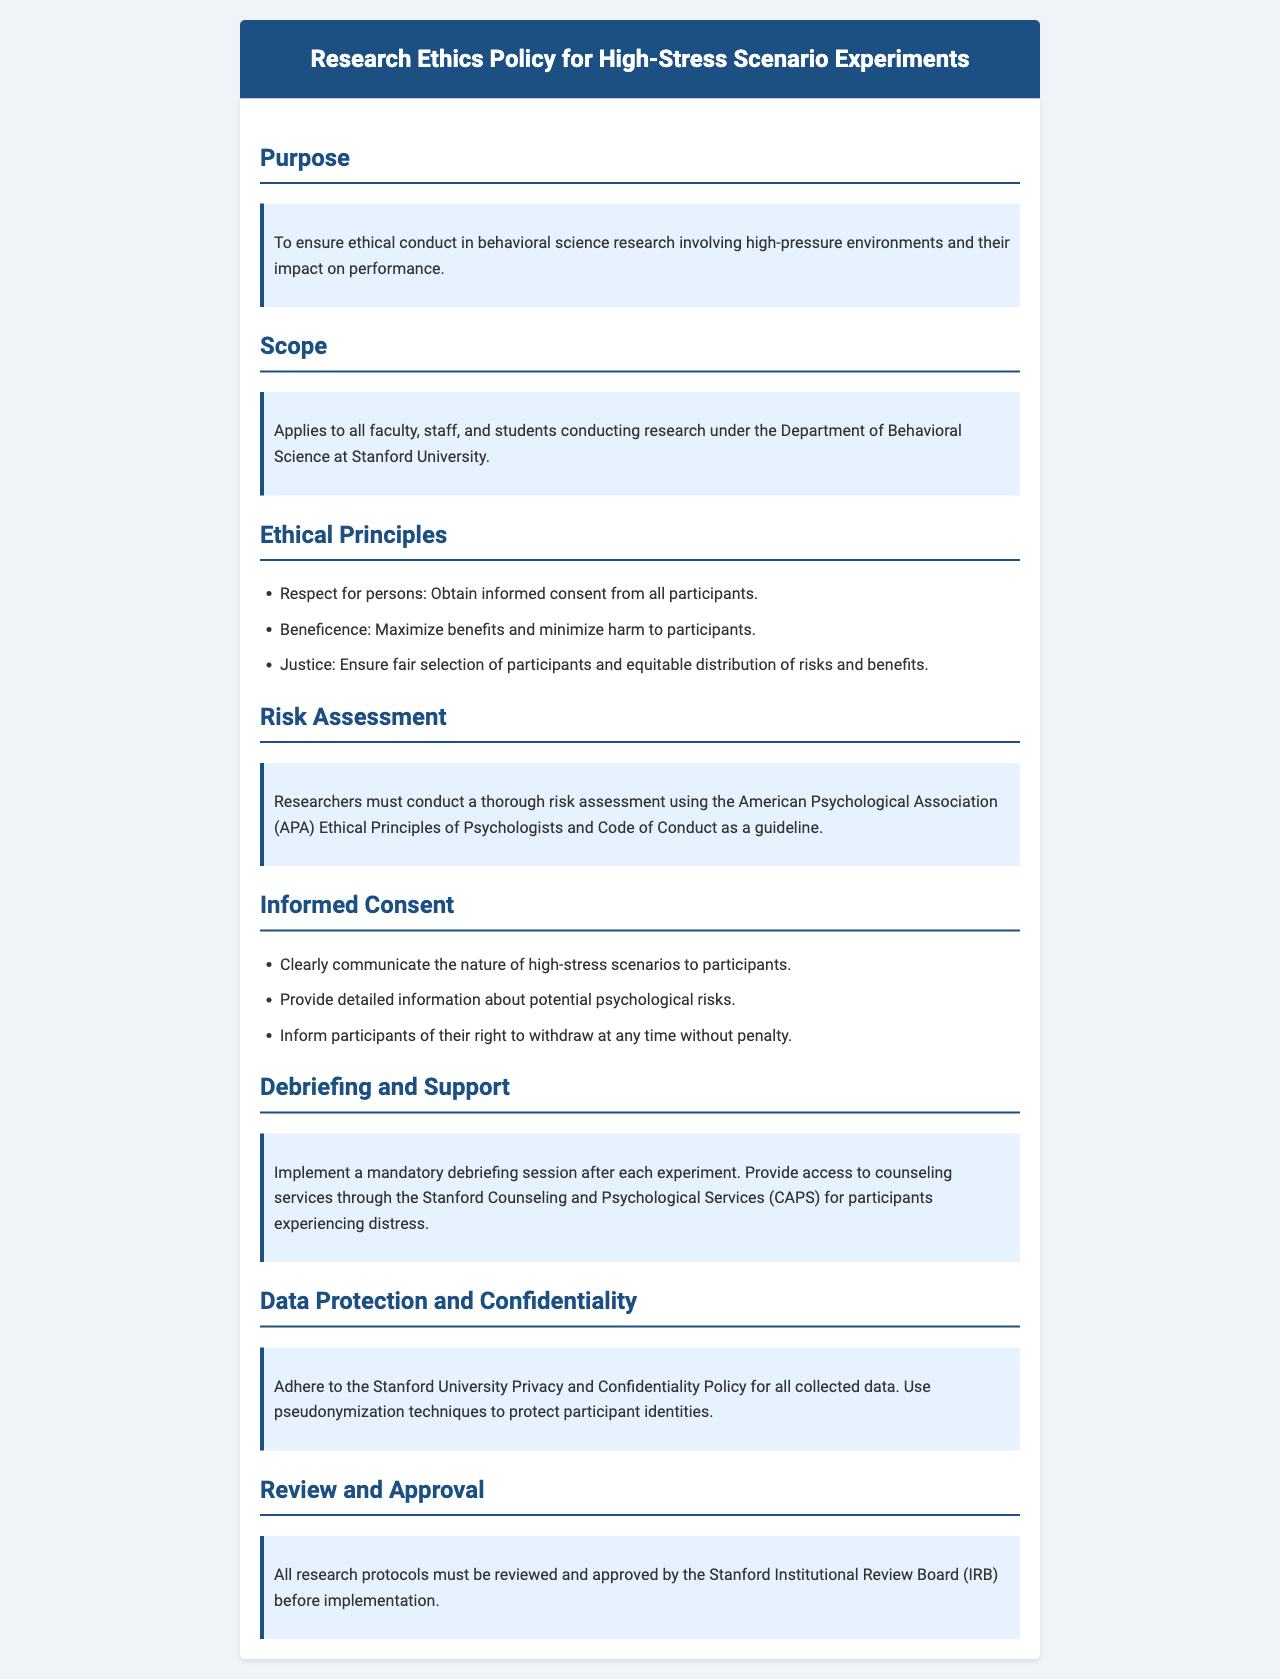What is the purpose of the policy? The purpose of the policy is to ensure ethical conduct in behavioral science research involving high-pressure environments and their impact on performance.
Answer: To ensure ethical conduct in behavioral science research involving high-pressure environments and their impact on performance Who does the policy apply to? The scope of the policy outlines that it applies to all faculty, staff, and students conducting research under the Department of Behavioral Science at Stanford University.
Answer: All faculty, staff, and students Name one ethical principle outlined in the document. The ethical principles section lists specific principles, one of which is respect for persons, focusing on obtaining informed consent.
Answer: Respect for persons What must researchers conduct according to the Risk Assessment section? The Risk Assessment section specifies that researchers must conduct a thorough risk assessment using the American Psychological Association (APA) guidelines.
Answer: A thorough risk assessment What is mandatory after each experiment? The debriefing and support section states that a mandatory debriefing session must be implemented after each experiment.
Answer: Mandatory debriefing session 